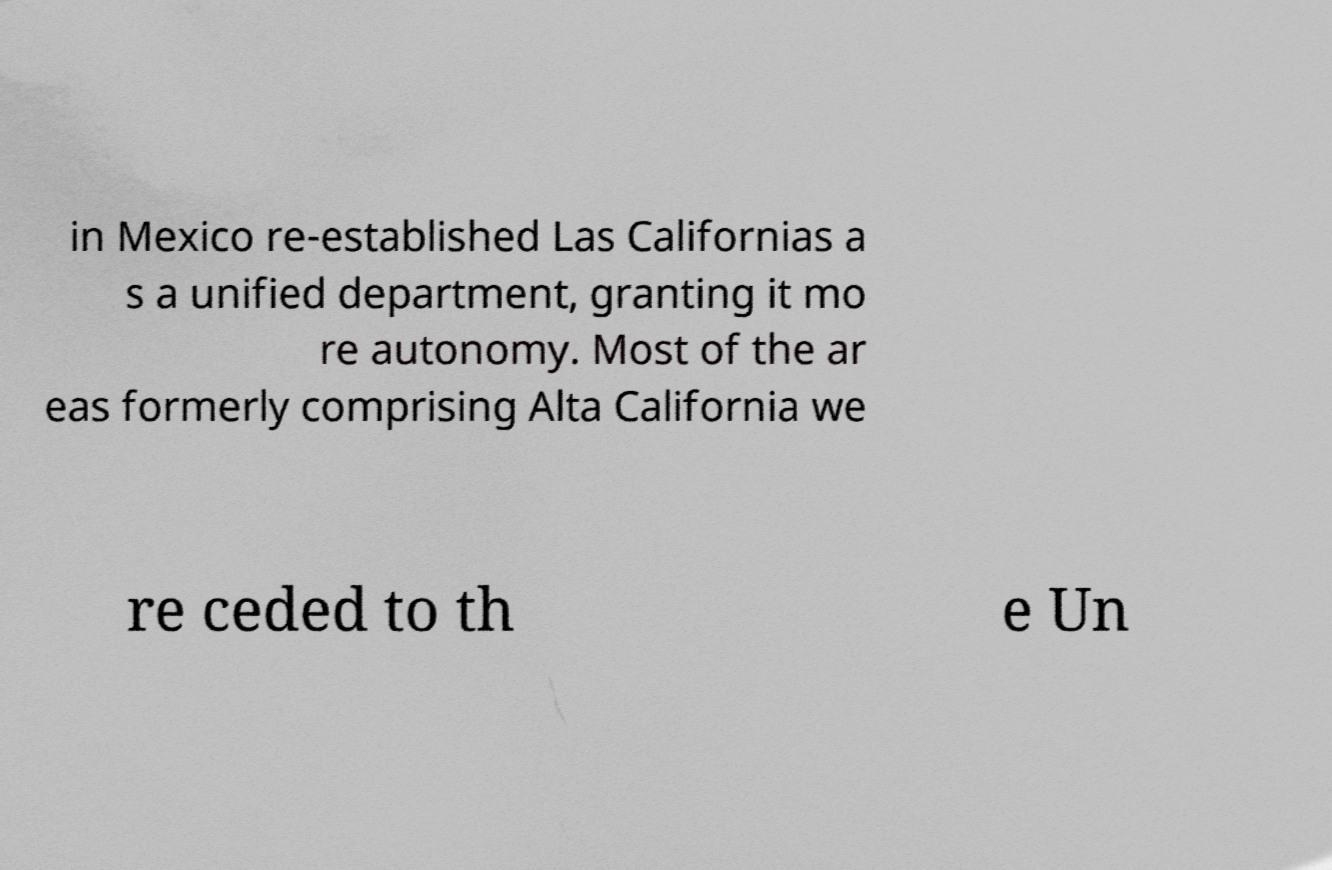Can you read and provide the text displayed in the image?This photo seems to have some interesting text. Can you extract and type it out for me? in Mexico re-established Las Californias a s a unified department, granting it mo re autonomy. Most of the ar eas formerly comprising Alta California we re ceded to th e Un 